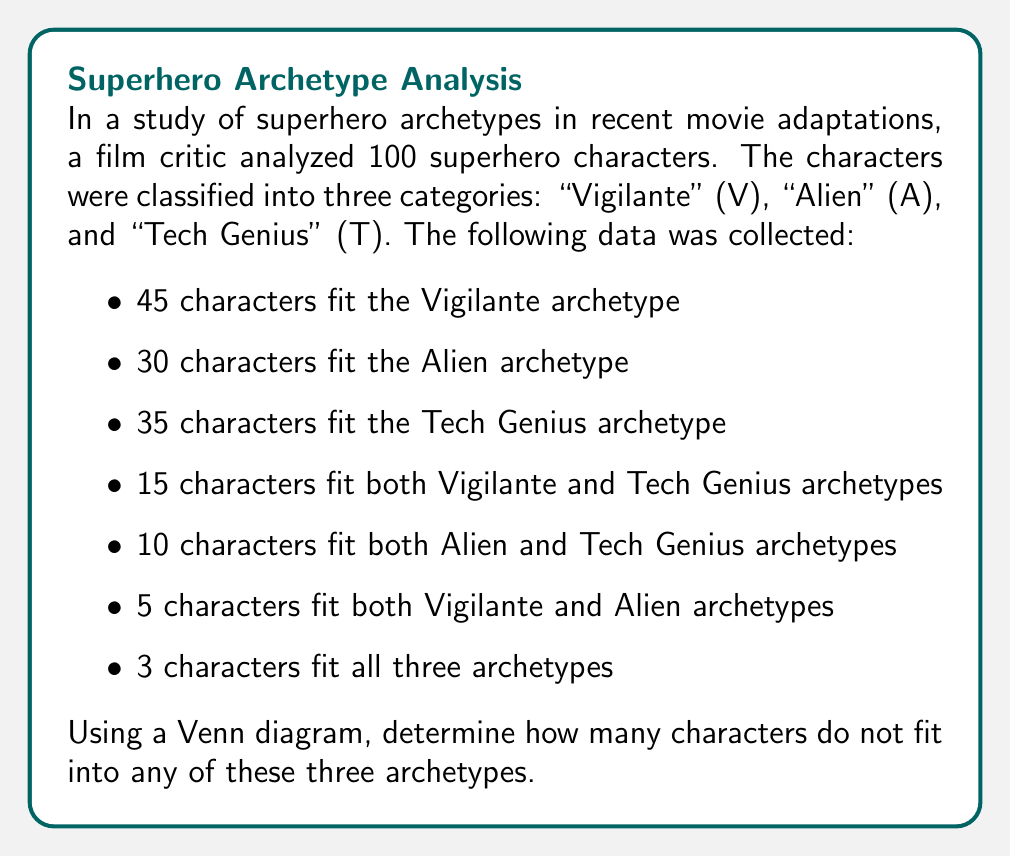What is the answer to this math problem? To solve this problem, we'll use a Venn diagram and the concept of sets. Let's break it down step-by-step:

1) First, let's draw a Venn diagram with three overlapping circles representing our sets:
   V (Vigilante), A (Alien), and T (Tech Genius).

[asy]
unitsize(1cm);

pair A = (0,0), B = (2,0), C = (1,1.7);
real r = 1.2;

draw(circle(A,r));
draw(circle(B,r));
draw(circle(C,r));

label("V", A + (-0.7,-0.7));
label("A", B + (0.7,-0.7));
label("T", C + (0,0.7));
[/asy]

2) Now, let's fill in the known values:
   - 3 in the center (fitting all three archetypes)
   - 5 in the overlap of V and A (minus the 3 in the center)
   - 10 in the overlap of A and T (minus the 3 in the center)
   - 15 in the overlap of V and T (minus the 3 in the center)

3) Let's define variables for the unknown regions:
   - Let $x$ be the number in V only
   - Let $y$ be the number in A only
   - Let $z$ be the number in T only

4) We can now set up equations based on the total for each set:

   V: $x + 12 + 2 + 3 = 45$
   A: $y + 2 + 7 + 3 = 30$
   T: $z + 7 + 12 + 3 = 35$

5) Solving these equations:
   $x = 28$
   $y = 18$
   $z = 13$

6) Now we can fill in all regions of our Venn diagram:

[asy]
unitsize(1cm);

pair A = (0,0), B = (2,0), C = (1,1.7);
real r = 1.2;

draw(circle(A,r));
draw(circle(B,r));
draw(circle(C,r));

label("V", A + (-0.7,-0.7));
label("A", B + (0.7,-0.7));
label("T", C + (0,0.7));

label("28", A + (-0.4,0.4));
label("18", B + (0.4,0.4));
label("13", C + (0,-0.4));

label("2", (A+B)/2);
label("12", (A+C)/2);
label("7", (B+C)/2);

label("3", (A+B+C)/3);
[/asy]

7) To find how many characters don't fit any archetype, we sum all the numbers in our diagram and subtract from 100:

   $100 - (28 + 18 + 13 + 2 + 12 + 7 + 3) = 100 - 83 = 17$

Therefore, 17 characters do not fit into any of these three archetypes.
Answer: 17 characters 